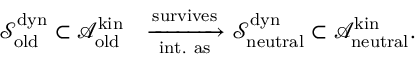Convert formula to latex. <formula><loc_0><loc_0><loc_500><loc_500>\begin{array} { r l } { \mathcal { S } _ { o l d } ^ { d y n } \subset \mathcal { A } _ { o l d } ^ { k i n } } & { \xrightarrow [ i n t . a s ] { s u r v i v e s } \mathcal { S } _ { n e u t r a l } ^ { d y n } \subset \mathcal { A } _ { n e u t r a l } ^ { k i n } . } \end{array}</formula> 